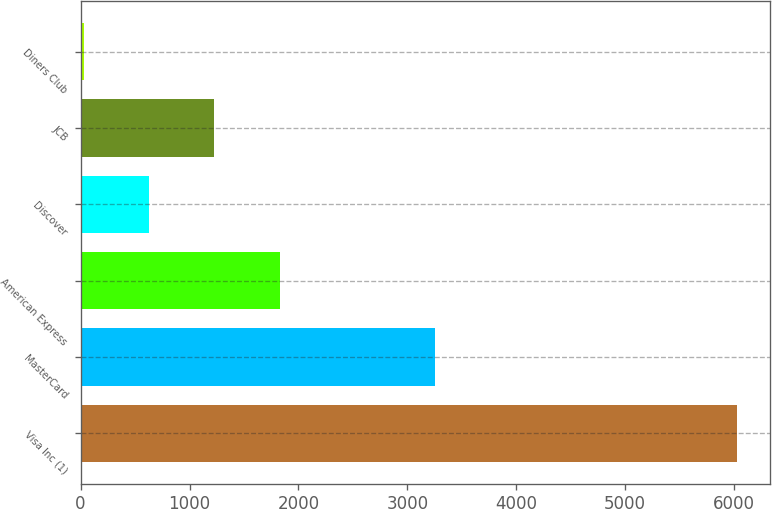Convert chart to OTSL. <chart><loc_0><loc_0><loc_500><loc_500><bar_chart><fcel>Visa Inc (1)<fcel>MasterCard<fcel>American Express<fcel>Discover<fcel>JCB<fcel>Diners Club<nl><fcel>6029<fcel>3249<fcel>1829<fcel>629<fcel>1229<fcel>29<nl></chart> 